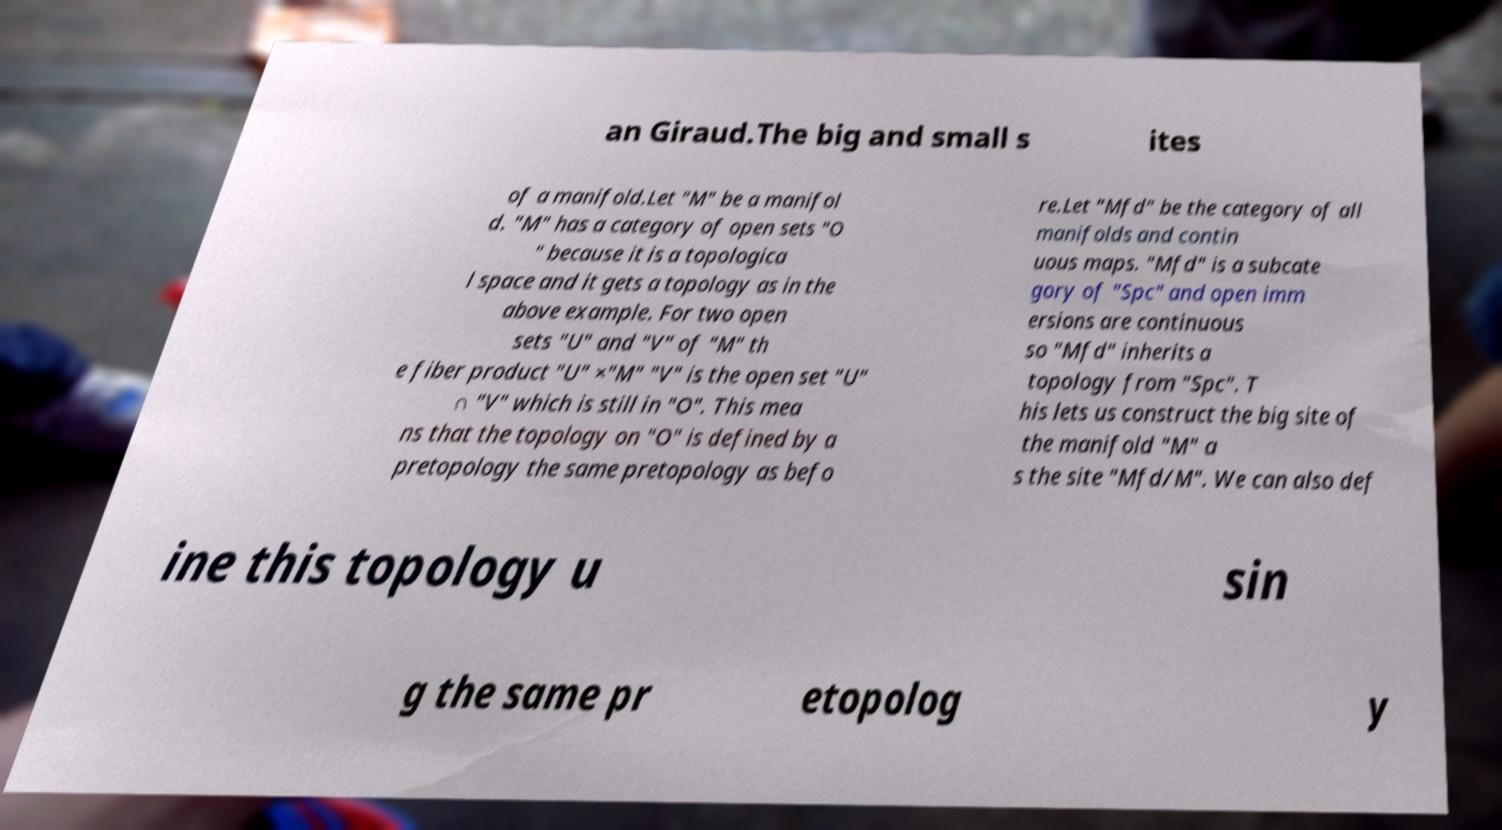Please read and relay the text visible in this image. What does it say? an Giraud.The big and small s ites of a manifold.Let "M" be a manifol d. "M" has a category of open sets "O " because it is a topologica l space and it gets a topology as in the above example. For two open sets "U" and "V" of "M" th e fiber product "U" ×"M" "V" is the open set "U" ∩ "V" which is still in "O". This mea ns that the topology on "O" is defined by a pretopology the same pretopology as befo re.Let "Mfd" be the category of all manifolds and contin uous maps. "Mfd" is a subcate gory of "Spc" and open imm ersions are continuous so "Mfd" inherits a topology from "Spc". T his lets us construct the big site of the manifold "M" a s the site "Mfd/M". We can also def ine this topology u sin g the same pr etopolog y 